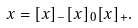Convert formula to latex. <formula><loc_0><loc_0><loc_500><loc_500>x = [ x ] _ { - } [ x ] _ { 0 } [ x ] _ { + } .</formula> 